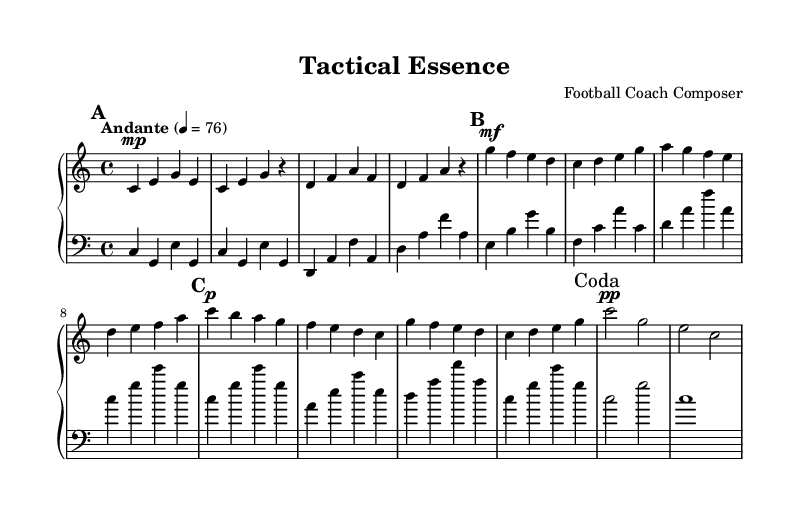What is the key signature of this music? The key signature is C major, which is indicated by the absence of any sharps or flats in the staff.
Answer: C major What is the time signature of this piece? The time signature is indicated as 4/4 at the beginning of the score, meaning there are four beats in each measure, and the quarter note receives one beat.
Answer: 4/4 What tempo marking is used in this piece? The tempo marking is provided as "Andante," which suggests a moderately slow pace, typically around 76 beats per minute.
Answer: Andante How many sections are there in the music? The music consists of three sections labeled A, B, and A', followed by a Coda, making it four distinct structural parts.
Answer: Four What is the dynamic marking at the beginning of the B section? The dynamic marking at the start of the B section is marked as mf, indicating a moderate volume level.
Answer: mf What is the final note in the Coda section? The final note in the Coda section is a whole note, which is represented by the note c, signaling the end of the piece.
Answer: c 